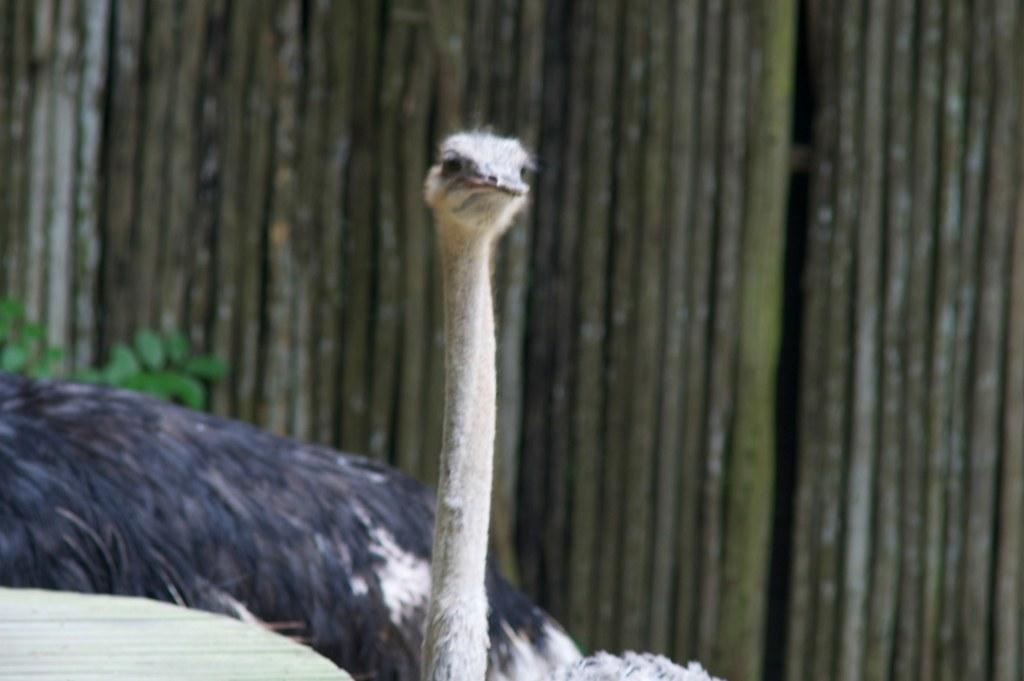What type of animal is present in the image? There is an ostrich in the image. What is the structure made of wooden sticks in the image? There is a wall made up of wooden sticks in the image. Are there any plants visible in the image? Yes, there are a few leaves of a plant in the image. What type of care is the ostrich receiving in the image? There is no indication in the image that the ostrich is receiving any care. Is there a church visible in the image? There is no church present in the image. 